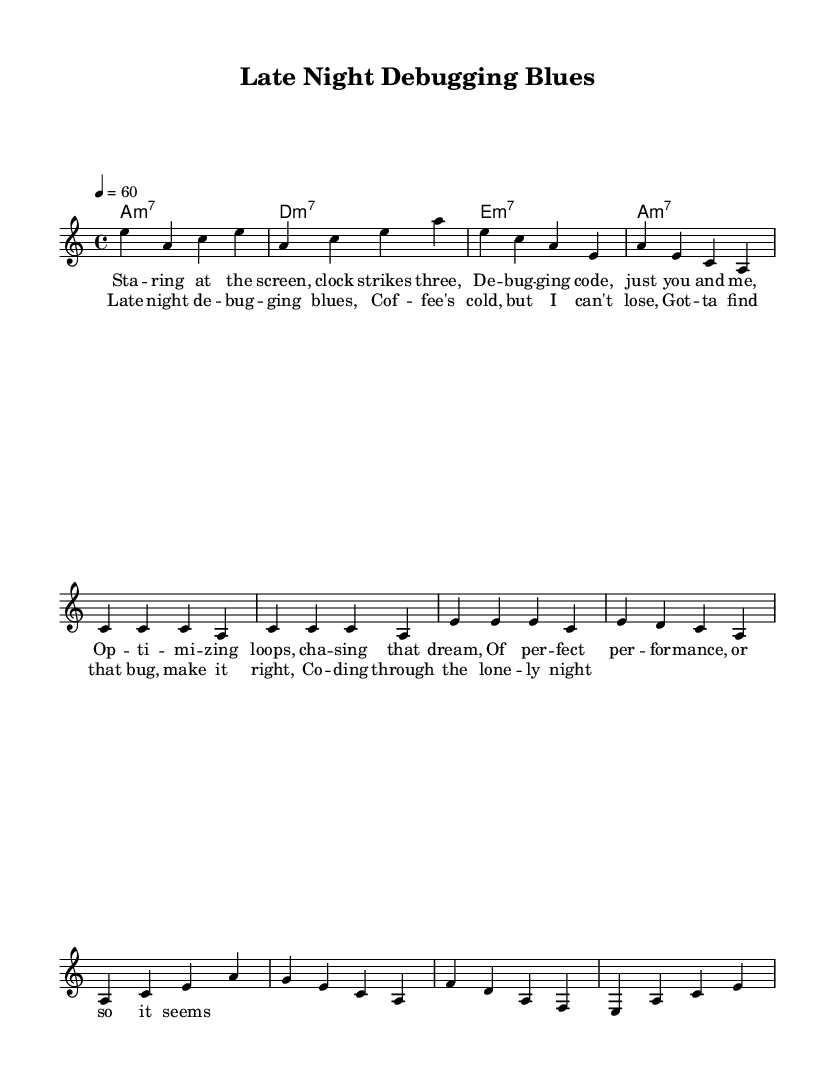What is the key signature of this music? The key signature indicates the song is in A minor, which has no sharps or flats.
Answer: A minor What is the time signature? The time signature shown is 4/4, meaning there are four beats per measure.
Answer: 4/4 What is the tempo marking? The tempo marking indicates a speed of 60 beats per minute (Largo), suggesting a slow pace.
Answer: 60 How many measures are in the melody section? Counting the measures in the melody portion reveals a total of 10 measures.
Answer: 10 What are the three main elements of this piece? The main elements are melody, harmony, and lyrics, which combine to form the complete piece.
Answer: Melody, harmony, lyrics Is there a specific chord progression reflected in the music? The chord progression consists of A minor 7, D minor 7, and E minor 7, which is typical for Blues music.
Answer: A minor 7, D minor 7, E minor 7 What theme is expressed in the lyrics? The lyrics express themes of late-night debugging sessions and the pursuit of optimal performance, reflecting personal struggles related to coding.
Answer: Late-night debugging and performance 